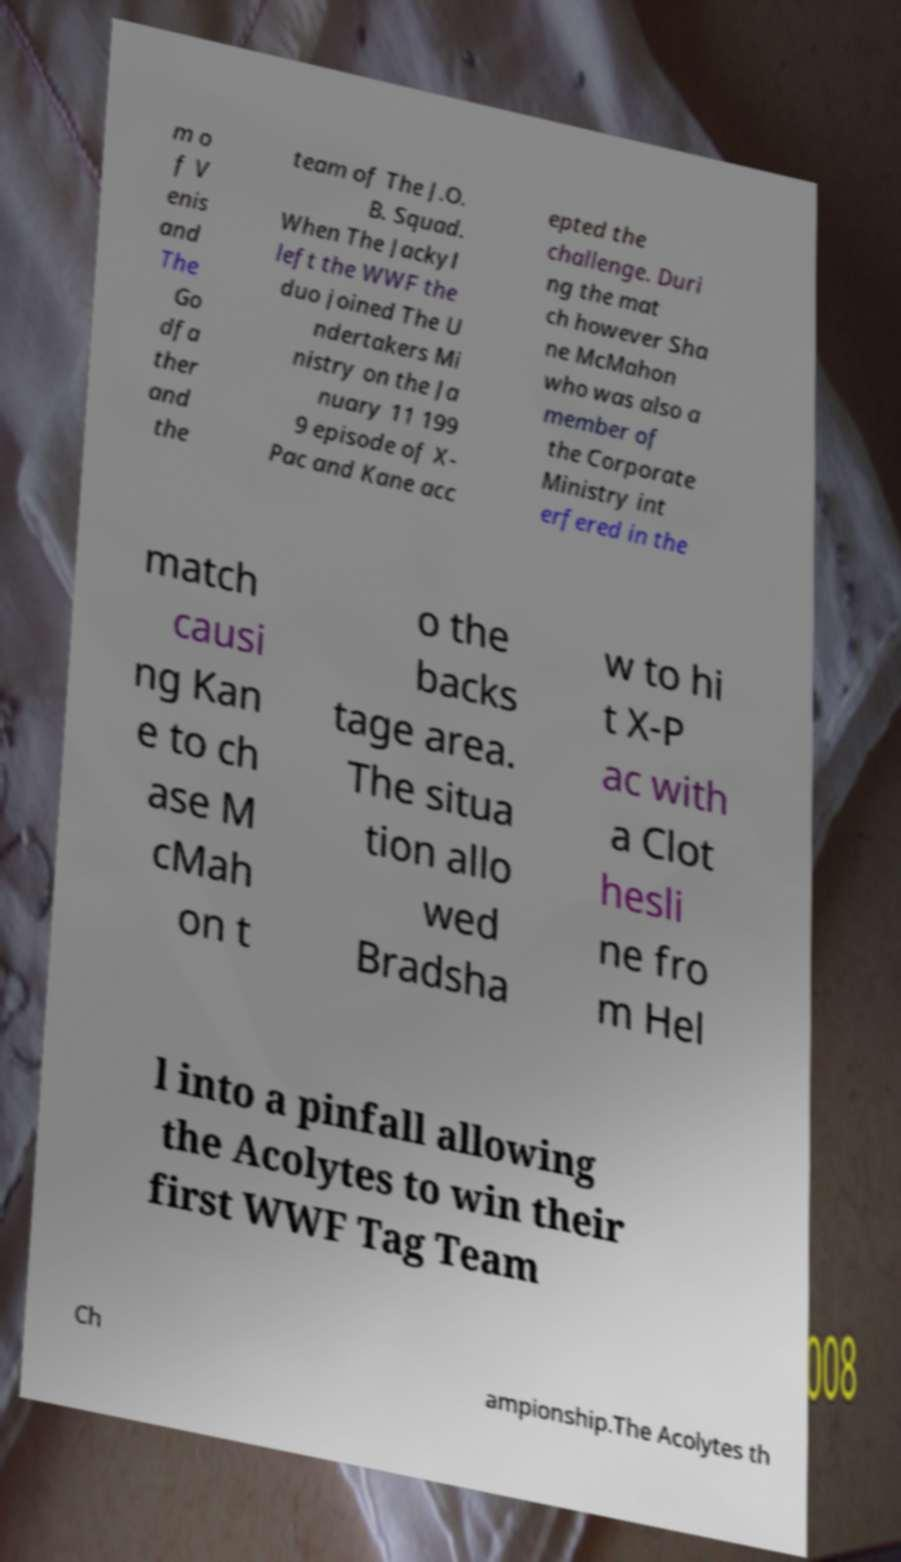Can you accurately transcribe the text from the provided image for me? m o f V enis and The Go dfa ther and the team of The J.O. B. Squad. When The Jackyl left the WWF the duo joined The U ndertakers Mi nistry on the Ja nuary 11 199 9 episode of X- Pac and Kane acc epted the challenge. Duri ng the mat ch however Sha ne McMahon who was also a member of the Corporate Ministry int erfered in the match causi ng Kan e to ch ase M cMah on t o the backs tage area. The situa tion allo wed Bradsha w to hi t X-P ac with a Clot hesli ne fro m Hel l into a pinfall allowing the Acolytes to win their first WWF Tag Team Ch ampionship.The Acolytes th 